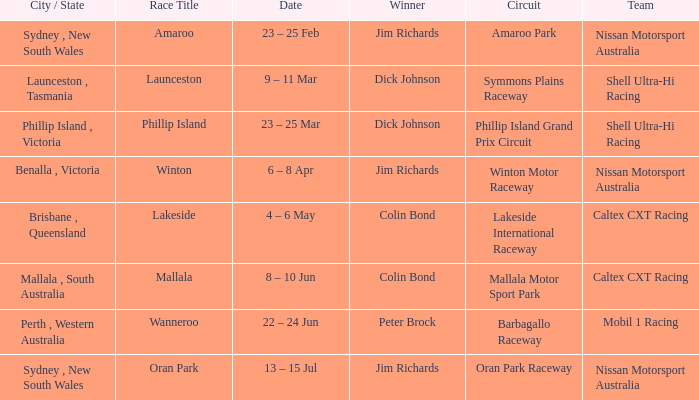Name the date for race title lakeside 4 – 6 May. 